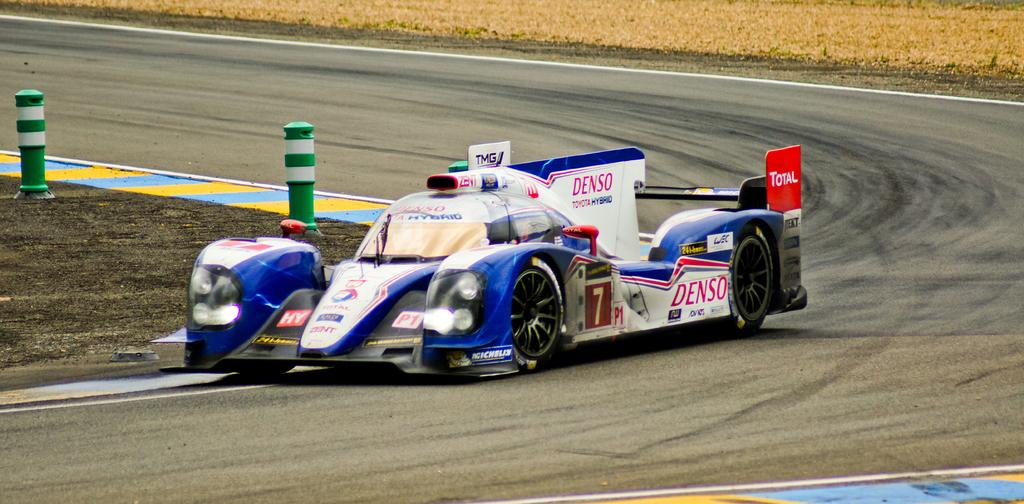What is happening in the image? There is a racing event taking place on a road. What can you tell about the road in the image? The road is blue and white in color. What type of balloon can be seen floating in the sky during the racing event? There is no balloon present in the image; it only shows a racing event on a blue and white road. 